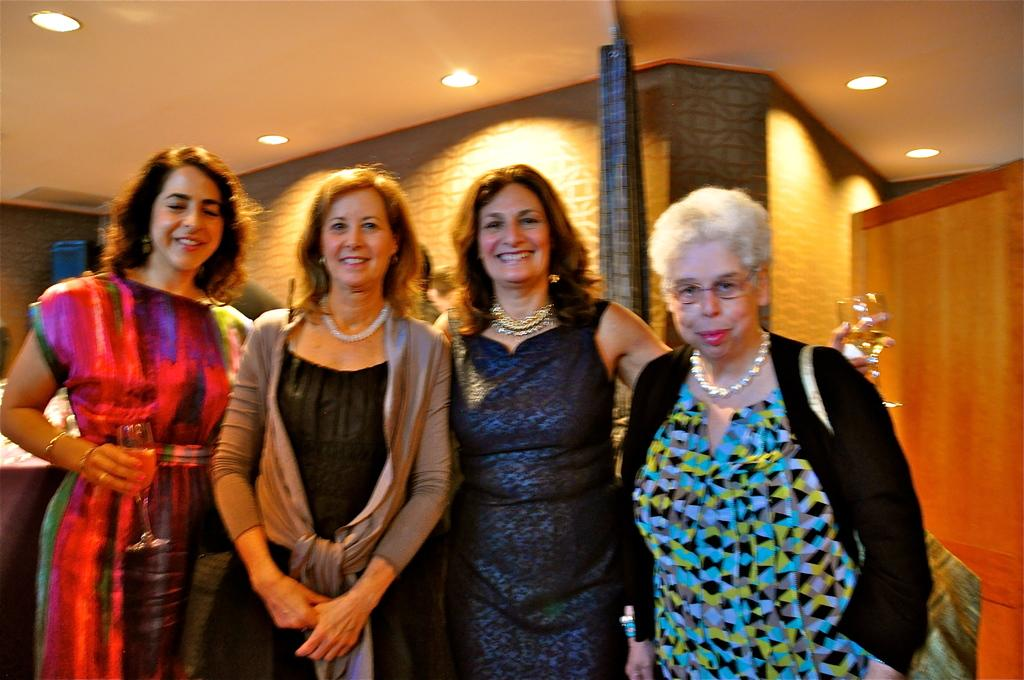What can be observed about the women in the image? There are women standing in the image, and they are smiling. What is visible in the background of the image? There is a curtain in the background of the image. What is located at the top of the image? There are lights at the top of the image. What type of bun is being prepared in the image? There is no bun or any indication of food preparation in the image. How many ducks are visible in the image? There are no ducks present in the image. 